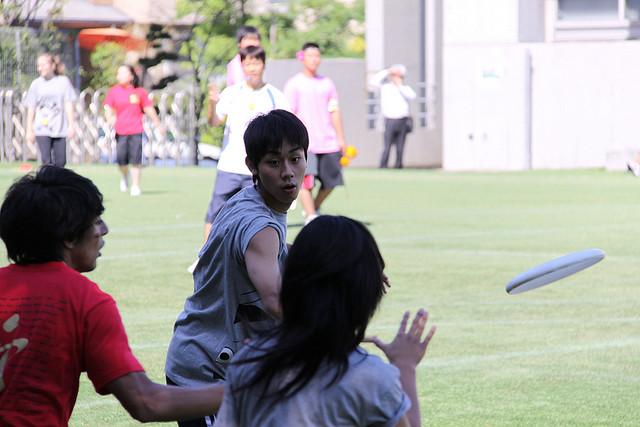Are they inside?
Short answer required. No. Is someone wearing a red shirt?
Quick response, please. Yes. What is the man throwing?
Answer briefly. Frisbee. 